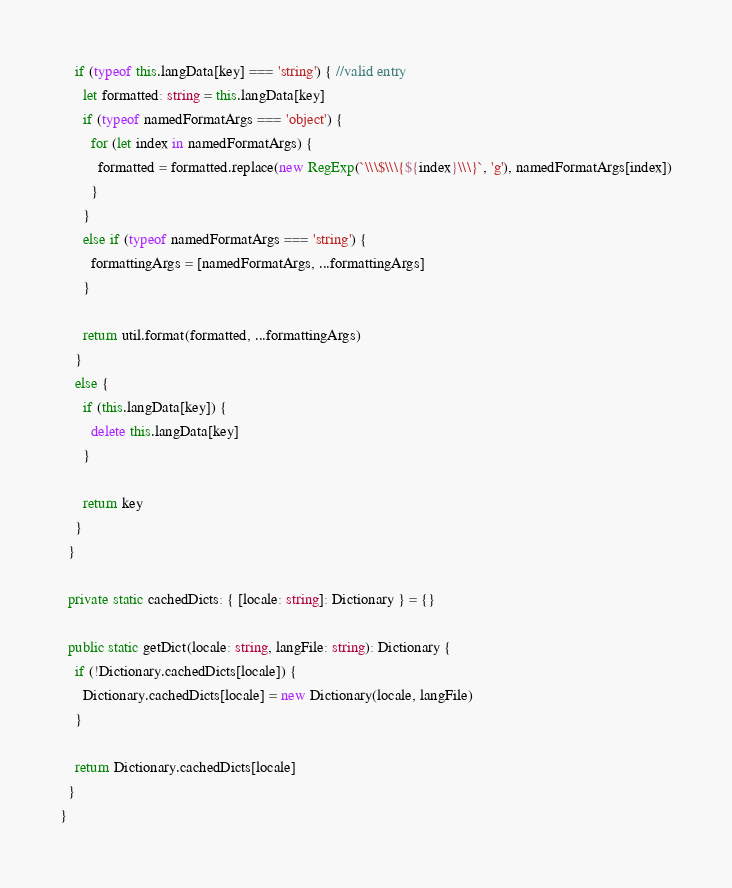Convert code to text. <code><loc_0><loc_0><loc_500><loc_500><_TypeScript_>    if (typeof this.langData[key] === 'string') { //valid entry
      let formatted: string = this.langData[key]
      if (typeof namedFormatArgs === 'object') {
        for (let index in namedFormatArgs) {
          formatted = formatted.replace(new RegExp(`\\\$\\\{${index}\\\}`, 'g'), namedFormatArgs[index])
        }
      }
      else if (typeof namedFormatArgs === 'string') {
        formattingArgs = [namedFormatArgs, ...formattingArgs]
      }

      return util.format(formatted, ...formattingArgs)
    }
    else {
      if (this.langData[key]) {
        delete this.langData[key]
      }

      return key
    }
  }

  private static cachedDicts: { [locale: string]: Dictionary } = {}

  public static getDict(locale: string, langFile: string): Dictionary {
    if (!Dictionary.cachedDicts[locale]) {
      Dictionary.cachedDicts[locale] = new Dictionary(locale, langFile)
    }

    return Dictionary.cachedDicts[locale]
  }
}
</code> 